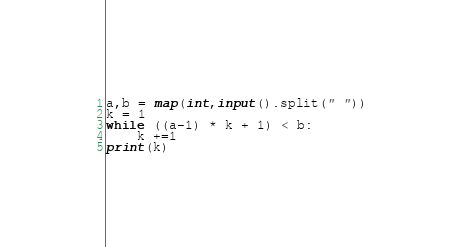Convert code to text. <code><loc_0><loc_0><loc_500><loc_500><_Python_>a,b = map(int,input().split(" "))
k = 1
while ((a-1) * k + 1) < b:
    k +=1
print(k)</code> 